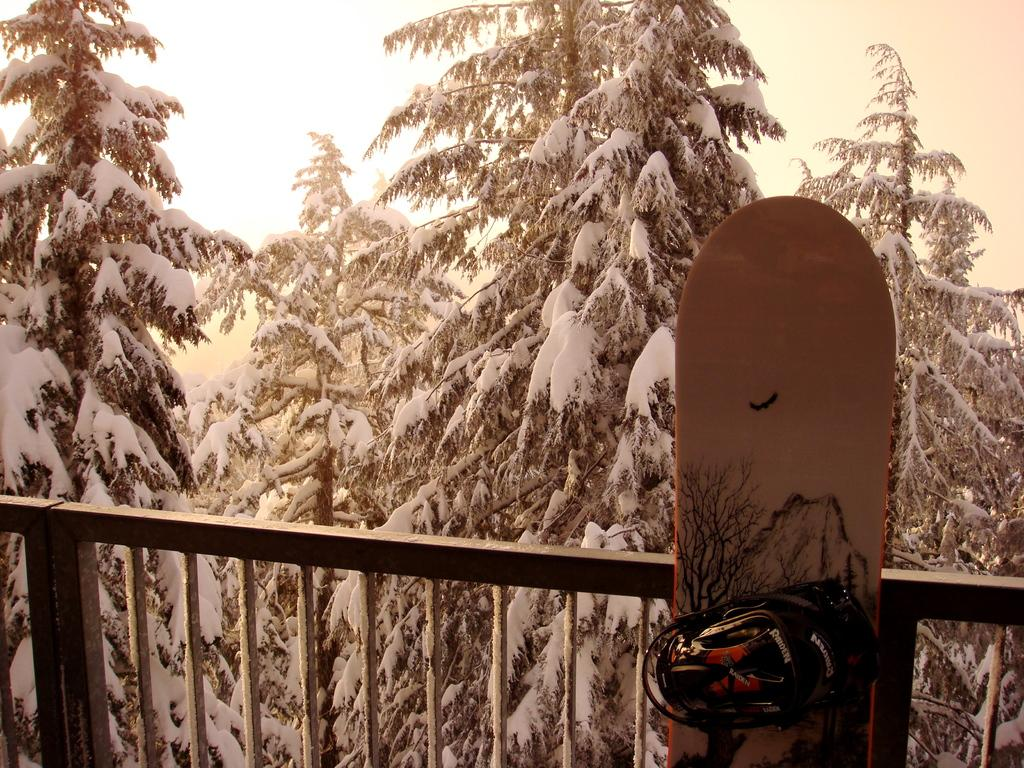What is located at the bottom of the image? There is a skating boat at the bottom of the image. What type of structure can be seen in the image? There is fencing in the image. What is the condition of the trees in the image? Trees covered with snow are visible behind the fencing. What is visible in the upper part of the image? The sky is present in the image. What type of tent is set up in the image? There is no tent present in the image. 